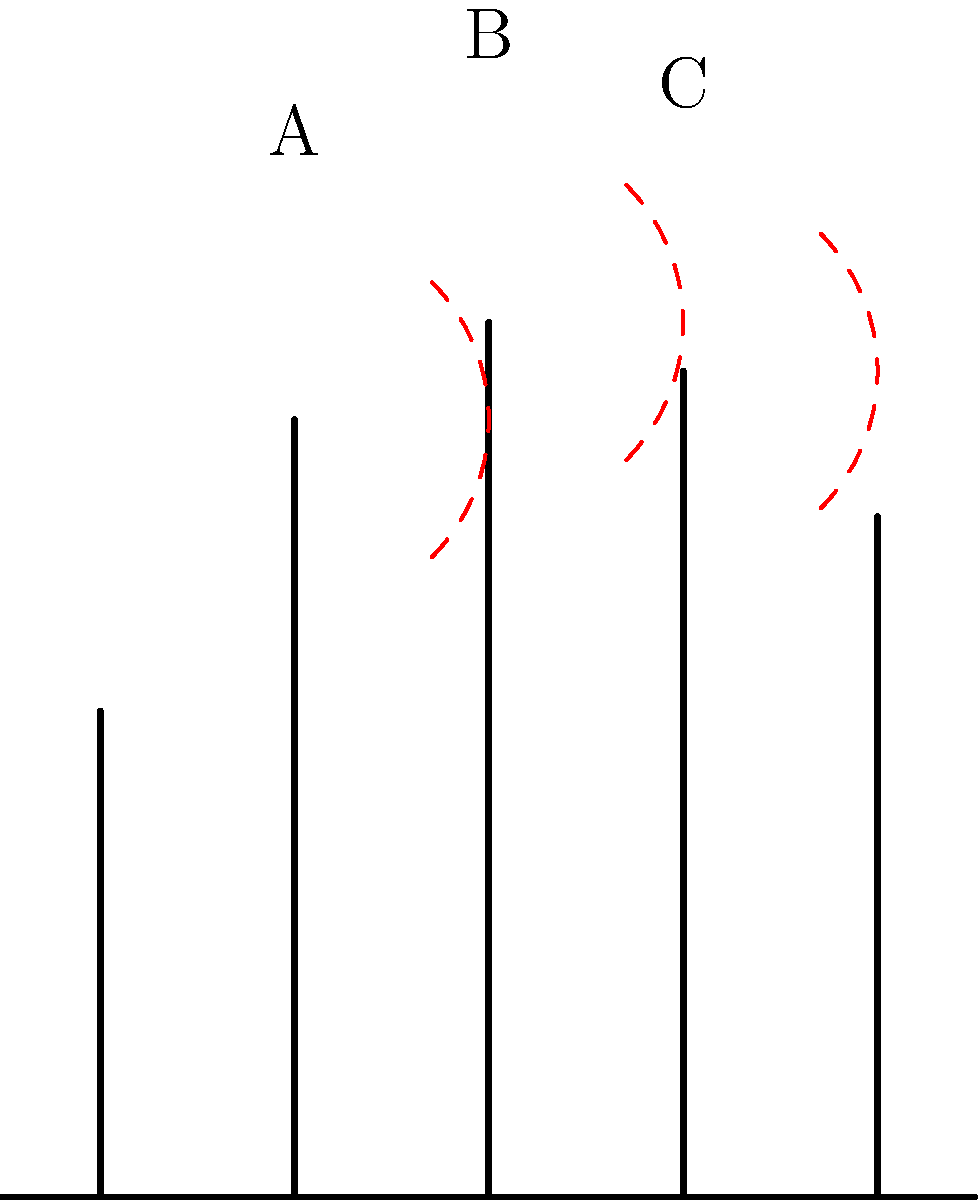In classical theatre, hand gestures play a crucial role in conveying emotions and intentions. The diagram above illustrates the range of motion for three fingers commonly used in expressive gestures. Which finger, labeled A, B, or C, typically has the greatest range of motion in theatrical hand movements, and how does this contribute to the overall expressiveness of gestures in classical performances? To answer this question, we need to analyze the diagram and consider the anatomical and theatrical implications:

1. Finger identification:
   A - Index finger
   B - Middle finger
   C - Ring finger

2. Range of motion analysis:
   - All three fingers show an arc representing their range of motion.
   - The arcs appear to be approximately the same size, suggesting a similar range of motion.
   - However, the middle finger (B) has the longest bone, which means its arc covers a larger area.

3. Anatomical considerations:
   - The middle finger is typically the longest and strongest finger.
   - It has more independent muscle control compared to the ring finger.
   - The index finger, while dexterous, usually has slightly less range than the middle finger.

4. Theatrical implications:
   - In classical theatre, the middle finger often leads hand gestures due to its prominence and range.
   - Extended middle finger gestures can create more visually striking and expressive shapes.
   - The greater range allows for more nuanced and varied movements in performance.

5. Expressive contribution:
   - The middle finger's greater range allows for more dramatic and noticeable gestures.
   - It can create clearer lines and shapes when viewed from a distance by the audience.
   - The extended reach of the middle finger can emphasize pointing gestures or symbolic hand positions.

Therefore, while all fingers contribute to expressive gestures, the middle finger (B) typically has the greatest range of motion and contributes significantly to the overall expressiveness of hand movements in classical theatrical performances.
Answer: B (Middle finger) 